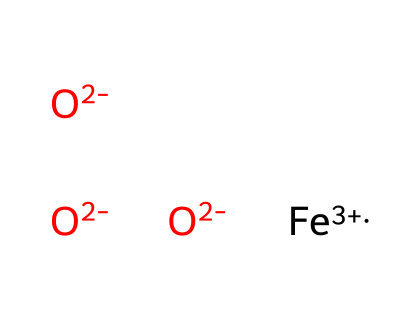What is the oxidation state of iron in this chemical? The chemical has an iron ion represented as [Fe+3], which indicates its oxidation state is +3.
Answer: +3 How many oxygen atoms are present in this chemical? The chemical structure shows three distinct [O-2] atoms connected to the iron, making a total of three oxygen atoms.
Answer: three What type of compound does this chemical represent? The presence of metallic iron and negatively charged oxygen ions suggests that this is a type of ionic compound. However, considering the properties typically associated with ionic liquids, it can be categorized as an ionic liquid.
Answer: ionic liquid What charge do the oxygen atoms have in this chemical? Each oxygen atom is represented as [O-2], which denotes that each oxygen carries a -2 charge.
Answer: -2 How many total charges does this compound have? There are one iron ion with a +3 charge and three oxygen ions each with a -2 charge, so the total charge calculation is +3 + (-2 * 3) = +3 - 6 = -3.
Answer: -3 